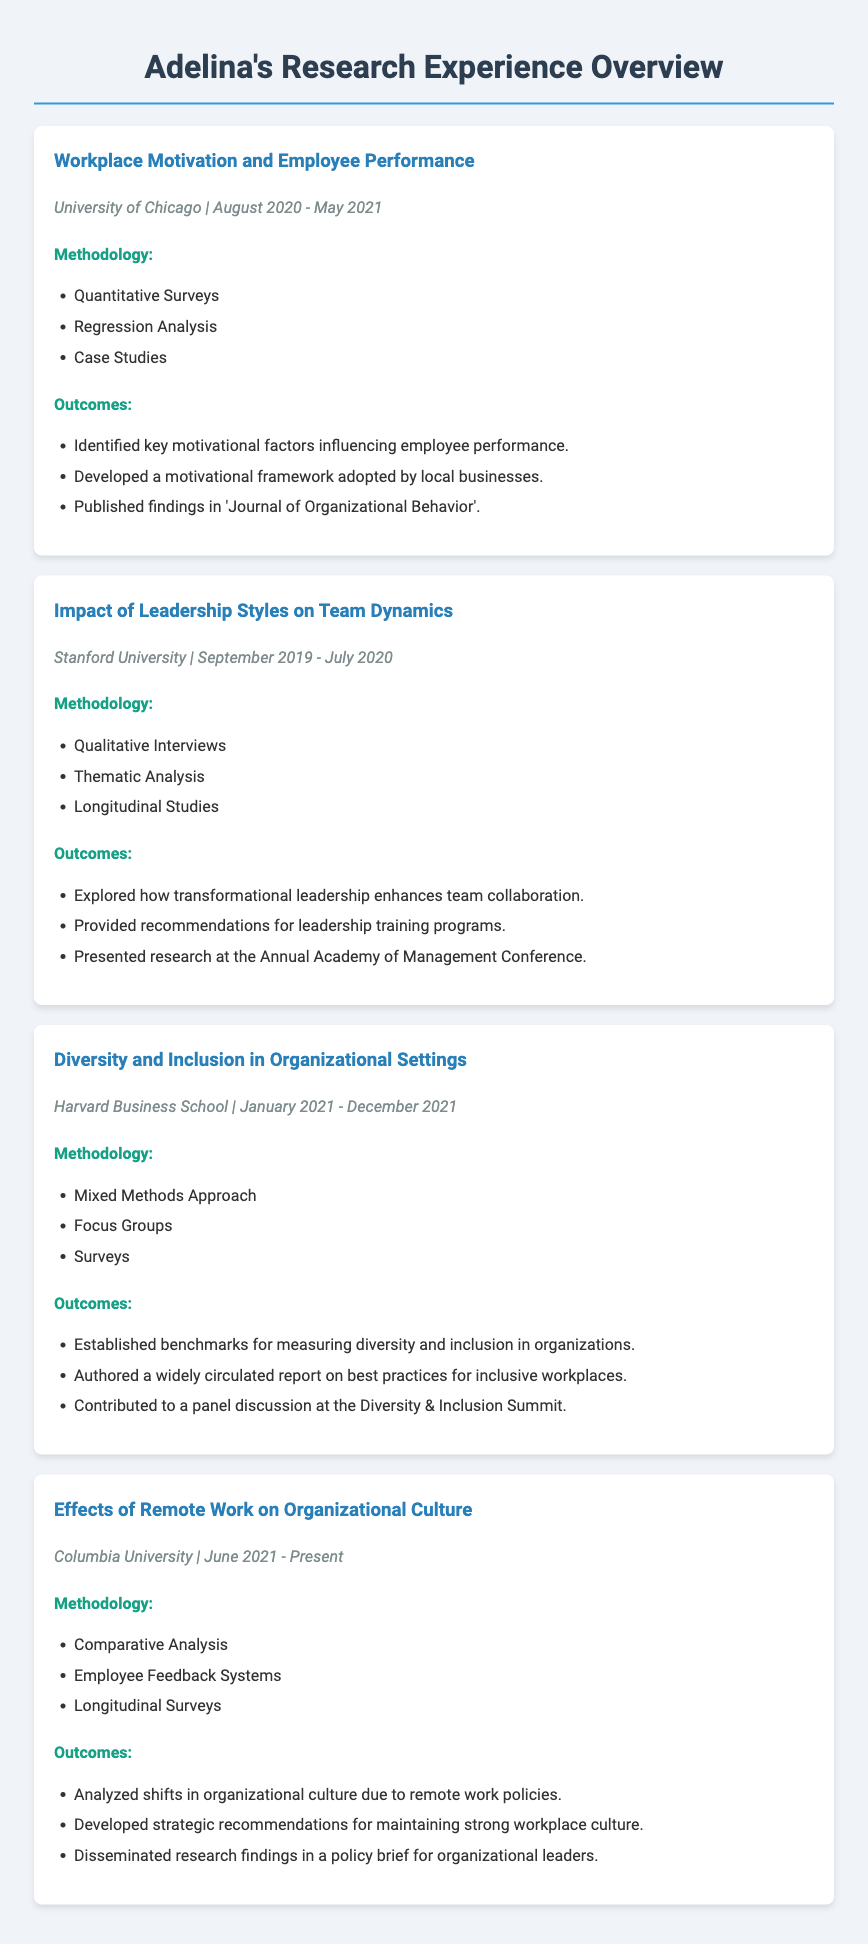What was the title of Adelina's project at the University of Chicago? The title of the project is explicitly stated in the document under the University of Chicago section.
Answer: Workplace Motivation and Employee Performance During which dates did Adelina conduct the project on Leadership Styles at Stanford University? The dates of the project are clearly mentioned in the project details for Stanford University.
Answer: September 2019 - July 2020 What methodology was used for the Diversity and Inclusion project at Harvard Business School? The methodology is listed under the Harvard Business School project section.
Answer: Mixed Methods Approach What was one of the outcomes of the Effects of Remote Work project at Columbia University? The outcomes are specifically outlined in the Columbia University project section.
Answer: Analyzed shifts in organizational culture due to remote work policies Which research conference did Adelina present her findings at? The conference name is mentioned in the project outcomes related to Leadership Styles.
Answer: Annual Academy of Management Conference How many key motivational factors influencing employee performance were identified in Adelina's study? The document highlights that key motivational factors were identified but does not specify a number, only stating that they were identified.
Answer: Key motivational factors What was the primary focus of the project conducted at Harvard Business School? The primary focus is derived from the title of the project listed in the document.
Answer: Diversity and Inclusion in Organizational Settings What type of analysis was conducted for the project on Employee Performance? The project methodology for Employee Performance specifies the type of analysis conducted.
Answer: Regression Analysis What is one recommendation provided by Adelina regarding leadership training? One of the recommendations is clearly mentioned in the outcomes of the Leadership Styles project.
Answer: Recommendations for leadership training programs 